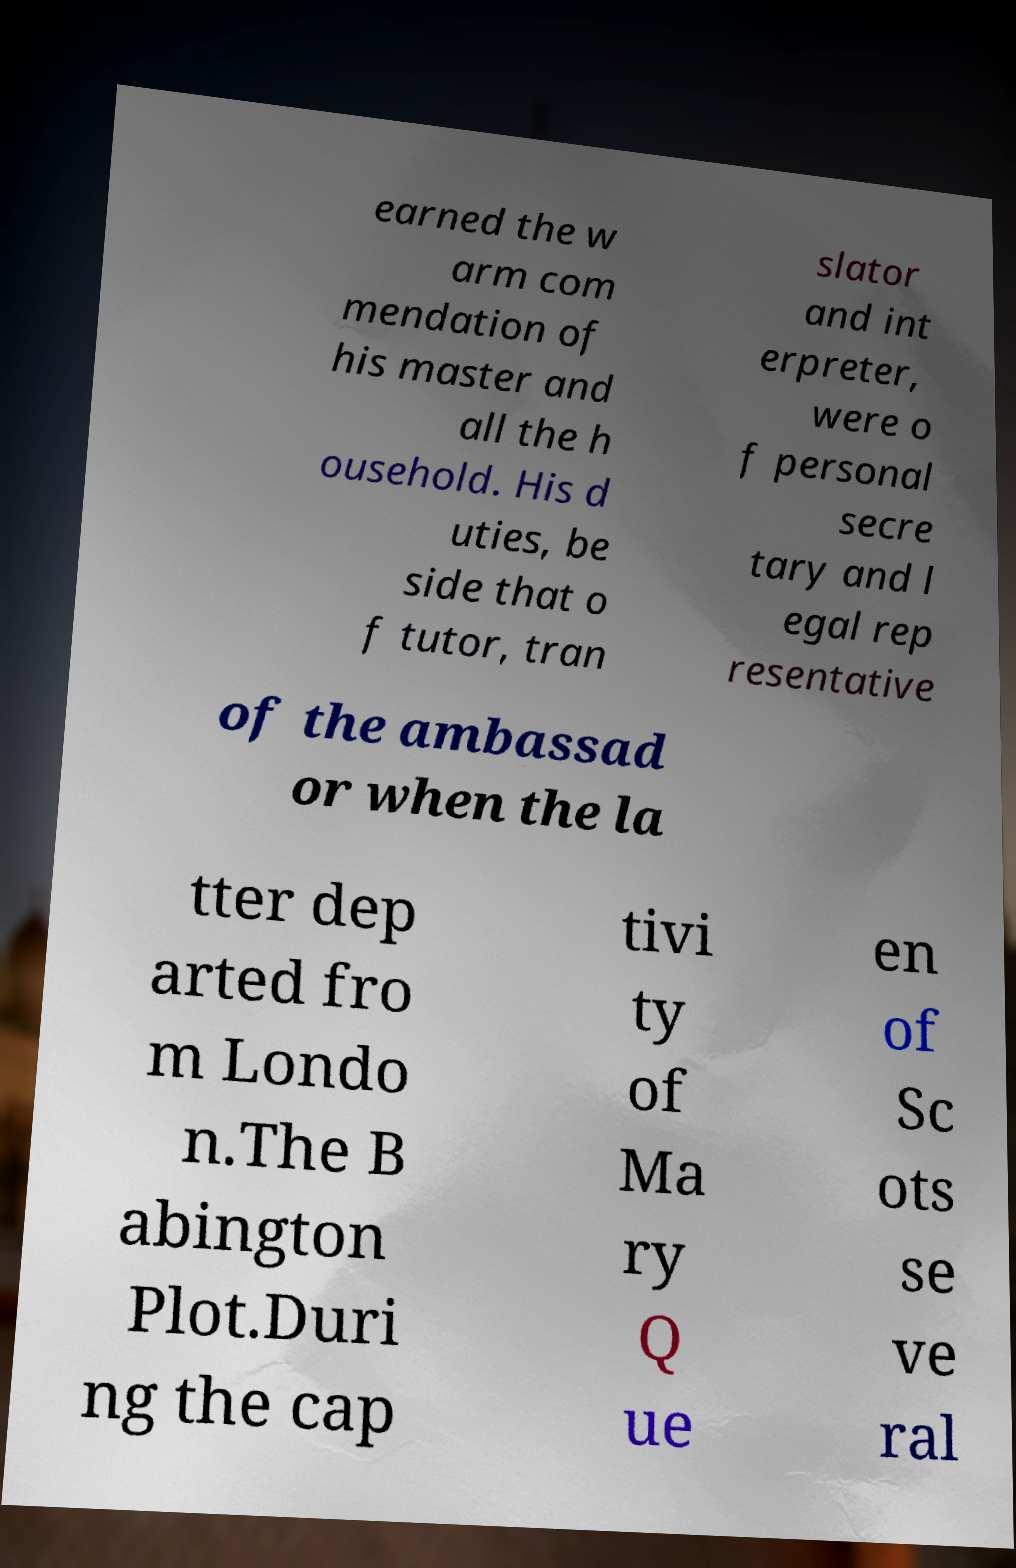I need the written content from this picture converted into text. Can you do that? earned the w arm com mendation of his master and all the h ousehold. His d uties, be side that o f tutor, tran slator and int erpreter, were o f personal secre tary and l egal rep resentative of the ambassad or when the la tter dep arted fro m Londo n.The B abington Plot.Duri ng the cap tivi ty of Ma ry Q ue en of Sc ots se ve ral 